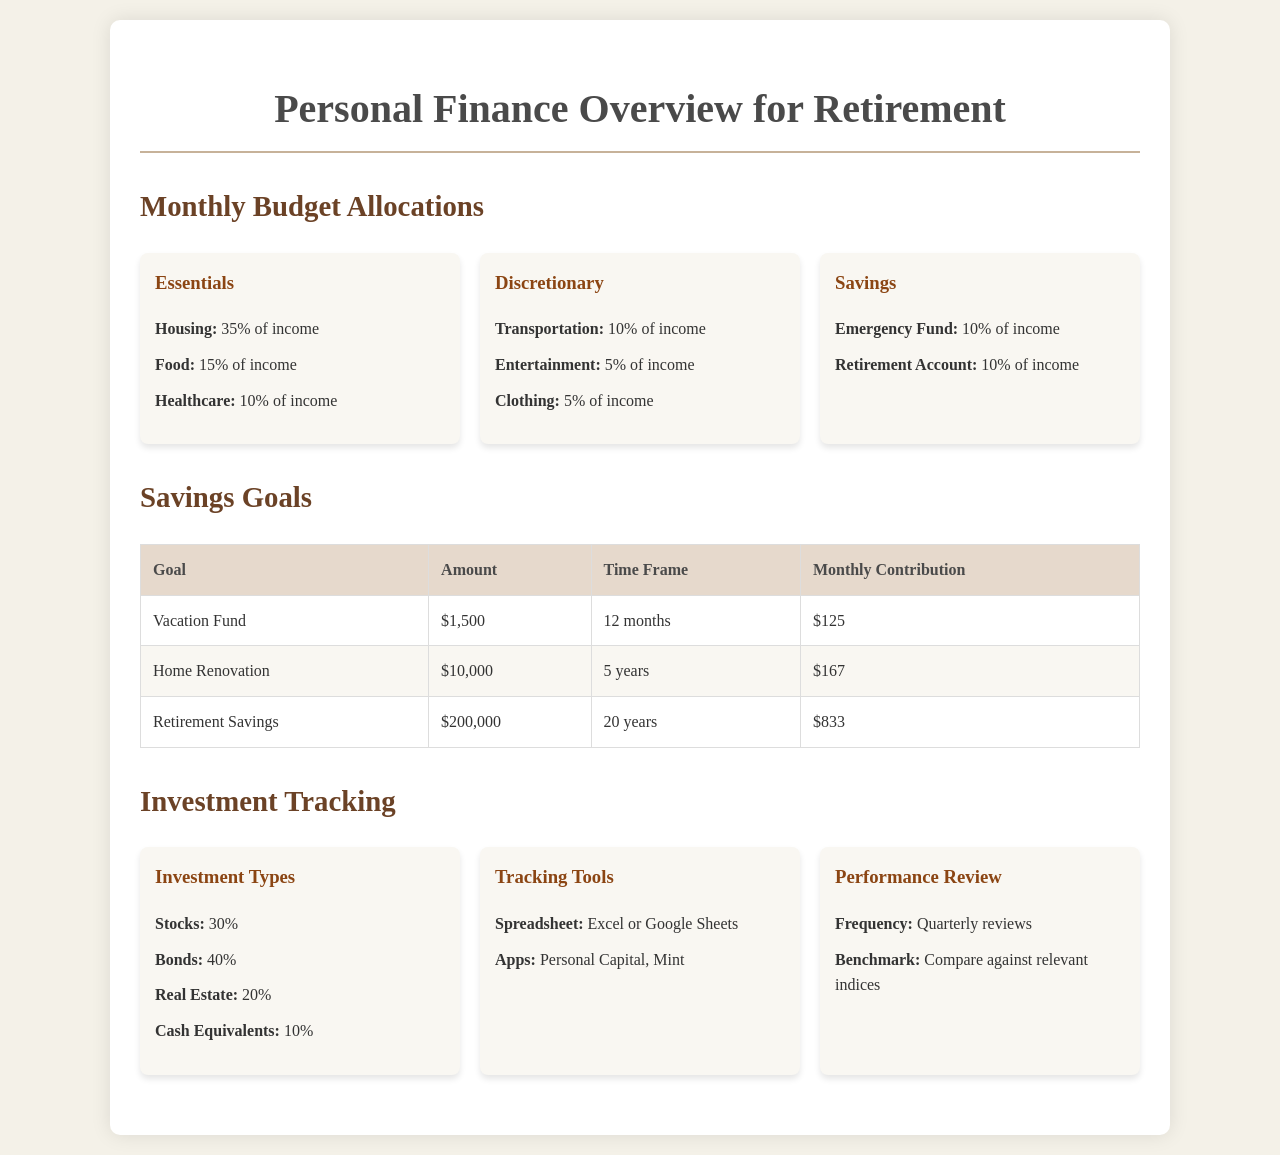What percentage of income is allocated to Housing? The document specifies that 35% of income is allocated to Housing under the Essentials section.
Answer: 35% What is the monthly contribution for the Vacation Fund? The document states that the monthly contribution for the Vacation Fund is $125 over a time frame of 12 months.
Answer: $125 How much is allocated to Bonds in the Investment Types? The document lists that 40% is allocated to Bonds under the Investment Types section.
Answer: 40% What is the total amount needed for Retirement Savings? The document shows that the total amount needed for Retirement Savings is $200,000.
Answer: $200,000 How often should investment performance be reviewed? The document mentions that investment performance reviews should occur quarterly.
Answer: Quarterly What is the percentage allocation for Cash Equivalents? The document indicates that 10% is allocated to Cash Equivalents in the Investment Types section.
Answer: 10% What is the goal amount for the Home Renovation? The document specifies that the goal amount for Home Renovation is $10,000.
Answer: $10,000 Which app is suggested for tracking investments? Personal Capital is mentioned as one of the suggested apps for tracking investments in the document.
Answer: Personal Capital What is the time frame for the Retirement Savings goal? The document states that the time frame for the Retirement Savings goal is 20 years.
Answer: 20 years 